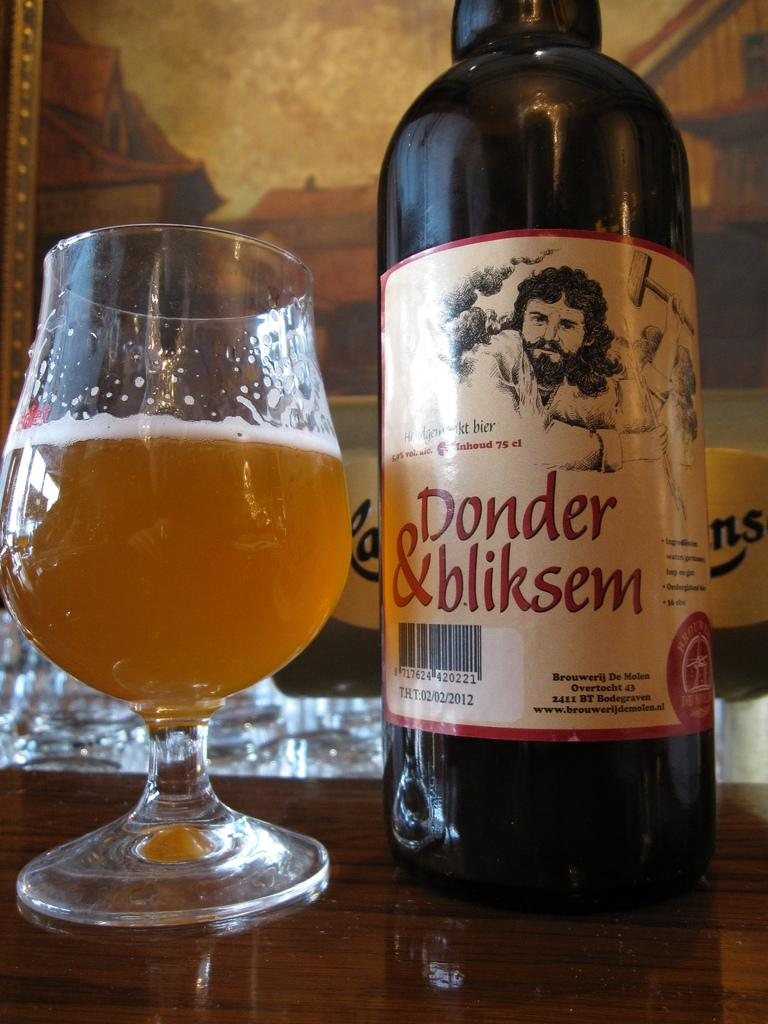<image>
Render a clear and concise summary of the photo. A glass with a short stem is three quarters of the way full of beer, next to a bottle of Donder & bliksen. 